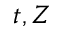<formula> <loc_0><loc_0><loc_500><loc_500>t , Z</formula> 